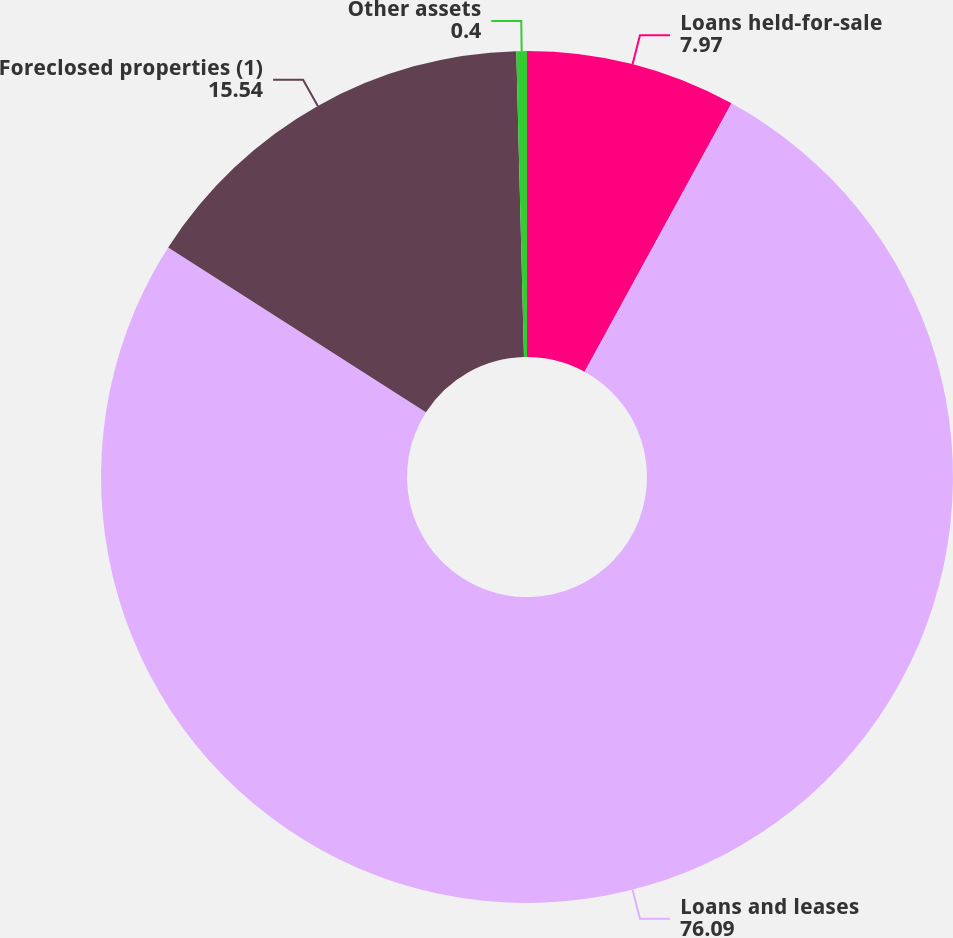Convert chart to OTSL. <chart><loc_0><loc_0><loc_500><loc_500><pie_chart><fcel>Loans held-for-sale<fcel>Loans and leases<fcel>Foreclosed properties (1)<fcel>Other assets<nl><fcel>7.97%<fcel>76.09%<fcel>15.54%<fcel>0.4%<nl></chart> 